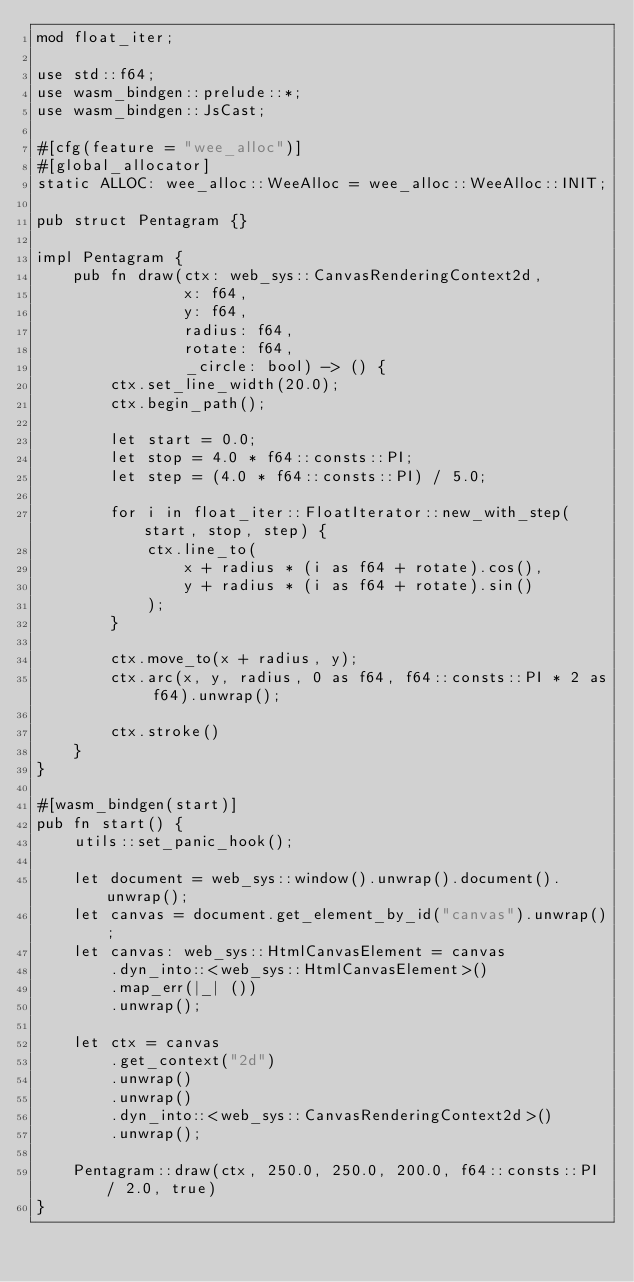<code> <loc_0><loc_0><loc_500><loc_500><_Rust_>mod float_iter;

use std::f64;
use wasm_bindgen::prelude::*;
use wasm_bindgen::JsCast;

#[cfg(feature = "wee_alloc")]
#[global_allocator]
static ALLOC: wee_alloc::WeeAlloc = wee_alloc::WeeAlloc::INIT;

pub struct Pentagram {}

impl Pentagram {
    pub fn draw(ctx: web_sys::CanvasRenderingContext2d,
                x: f64,
                y: f64,
                radius: f64,
                rotate: f64,
                _circle: bool) -> () {
        ctx.set_line_width(20.0);
        ctx.begin_path();

        let start = 0.0;
        let stop = 4.0 * f64::consts::PI;
        let step = (4.0 * f64::consts::PI) / 5.0;

        for i in float_iter::FloatIterator::new_with_step(start, stop, step) {
            ctx.line_to(
                x + radius * (i as f64 + rotate).cos(),
                y + radius * (i as f64 + rotate).sin()
            );
        }
        
        ctx.move_to(x + radius, y);
        ctx.arc(x, y, radius, 0 as f64, f64::consts::PI * 2 as f64).unwrap();
        
        ctx.stroke()
    }
}

#[wasm_bindgen(start)]
pub fn start() {
    utils::set_panic_hook();
    
    let document = web_sys::window().unwrap().document().unwrap();
    let canvas = document.get_element_by_id("canvas").unwrap();
    let canvas: web_sys::HtmlCanvasElement = canvas
        .dyn_into::<web_sys::HtmlCanvasElement>()
        .map_err(|_| ())
        .unwrap();

    let ctx = canvas
        .get_context("2d")
        .unwrap()
        .unwrap()
        .dyn_into::<web_sys::CanvasRenderingContext2d>()
        .unwrap();

    Pentagram::draw(ctx, 250.0, 250.0, 200.0, f64::consts::PI / 2.0, true)
}
</code> 